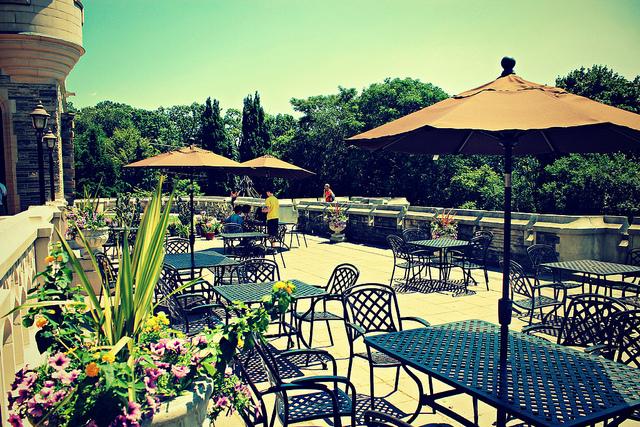Are there two umbrellas touching?
Be succinct. No. Is everyone sitting down?
Write a very short answer. No. Is this an indoor area?
Quick response, please. No. 